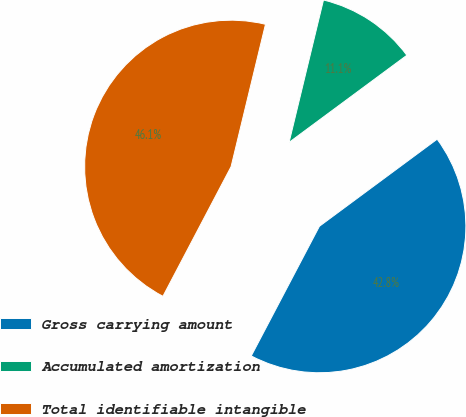Convert chart. <chart><loc_0><loc_0><loc_500><loc_500><pie_chart><fcel>Gross carrying amount<fcel>Accumulated amortization<fcel>Total identifiable intangible<nl><fcel>42.84%<fcel>11.09%<fcel>46.07%<nl></chart> 